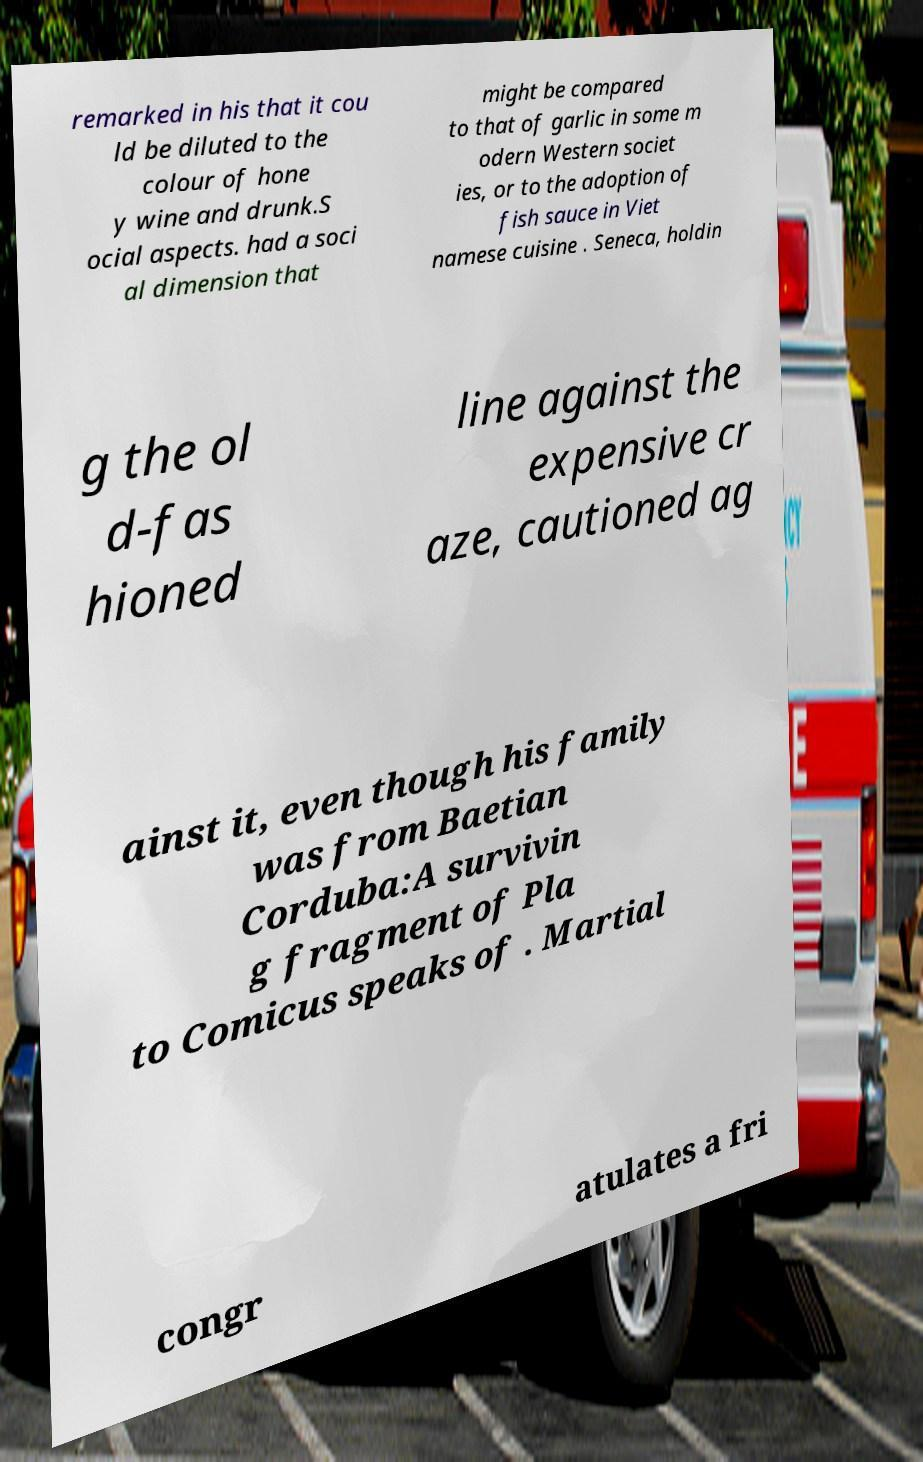Can you accurately transcribe the text from the provided image for me? remarked in his that it cou ld be diluted to the colour of hone y wine and drunk.S ocial aspects. had a soci al dimension that might be compared to that of garlic in some m odern Western societ ies, or to the adoption of fish sauce in Viet namese cuisine . Seneca, holdin g the ol d-fas hioned line against the expensive cr aze, cautioned ag ainst it, even though his family was from Baetian Corduba:A survivin g fragment of Pla to Comicus speaks of . Martial congr atulates a fri 